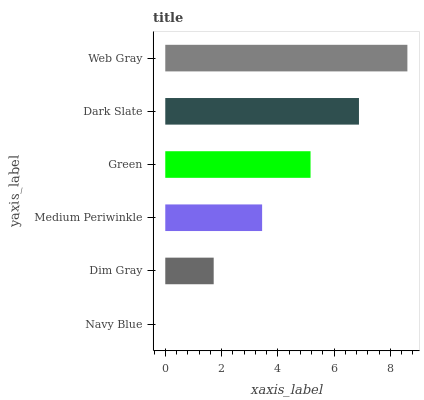Is Navy Blue the minimum?
Answer yes or no. Yes. Is Web Gray the maximum?
Answer yes or no. Yes. Is Dim Gray the minimum?
Answer yes or no. No. Is Dim Gray the maximum?
Answer yes or no. No. Is Dim Gray greater than Navy Blue?
Answer yes or no. Yes. Is Navy Blue less than Dim Gray?
Answer yes or no. Yes. Is Navy Blue greater than Dim Gray?
Answer yes or no. No. Is Dim Gray less than Navy Blue?
Answer yes or no. No. Is Green the high median?
Answer yes or no. Yes. Is Medium Periwinkle the low median?
Answer yes or no. Yes. Is Dark Slate the high median?
Answer yes or no. No. Is Dark Slate the low median?
Answer yes or no. No. 